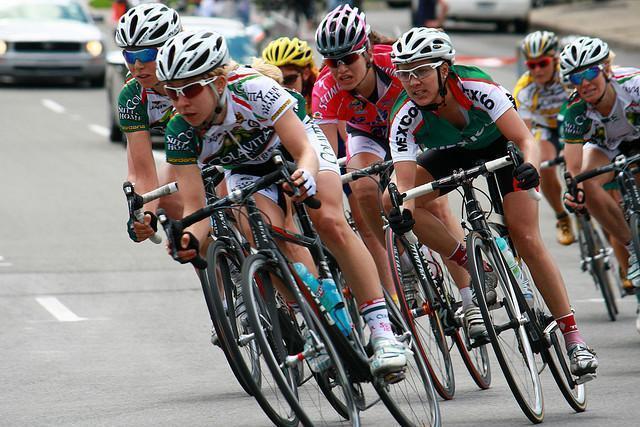What are the women participating in?
Make your selection from the four choices given to correctly answer the question.
Options: Exercise class, work group, group meeting, race. Race. 